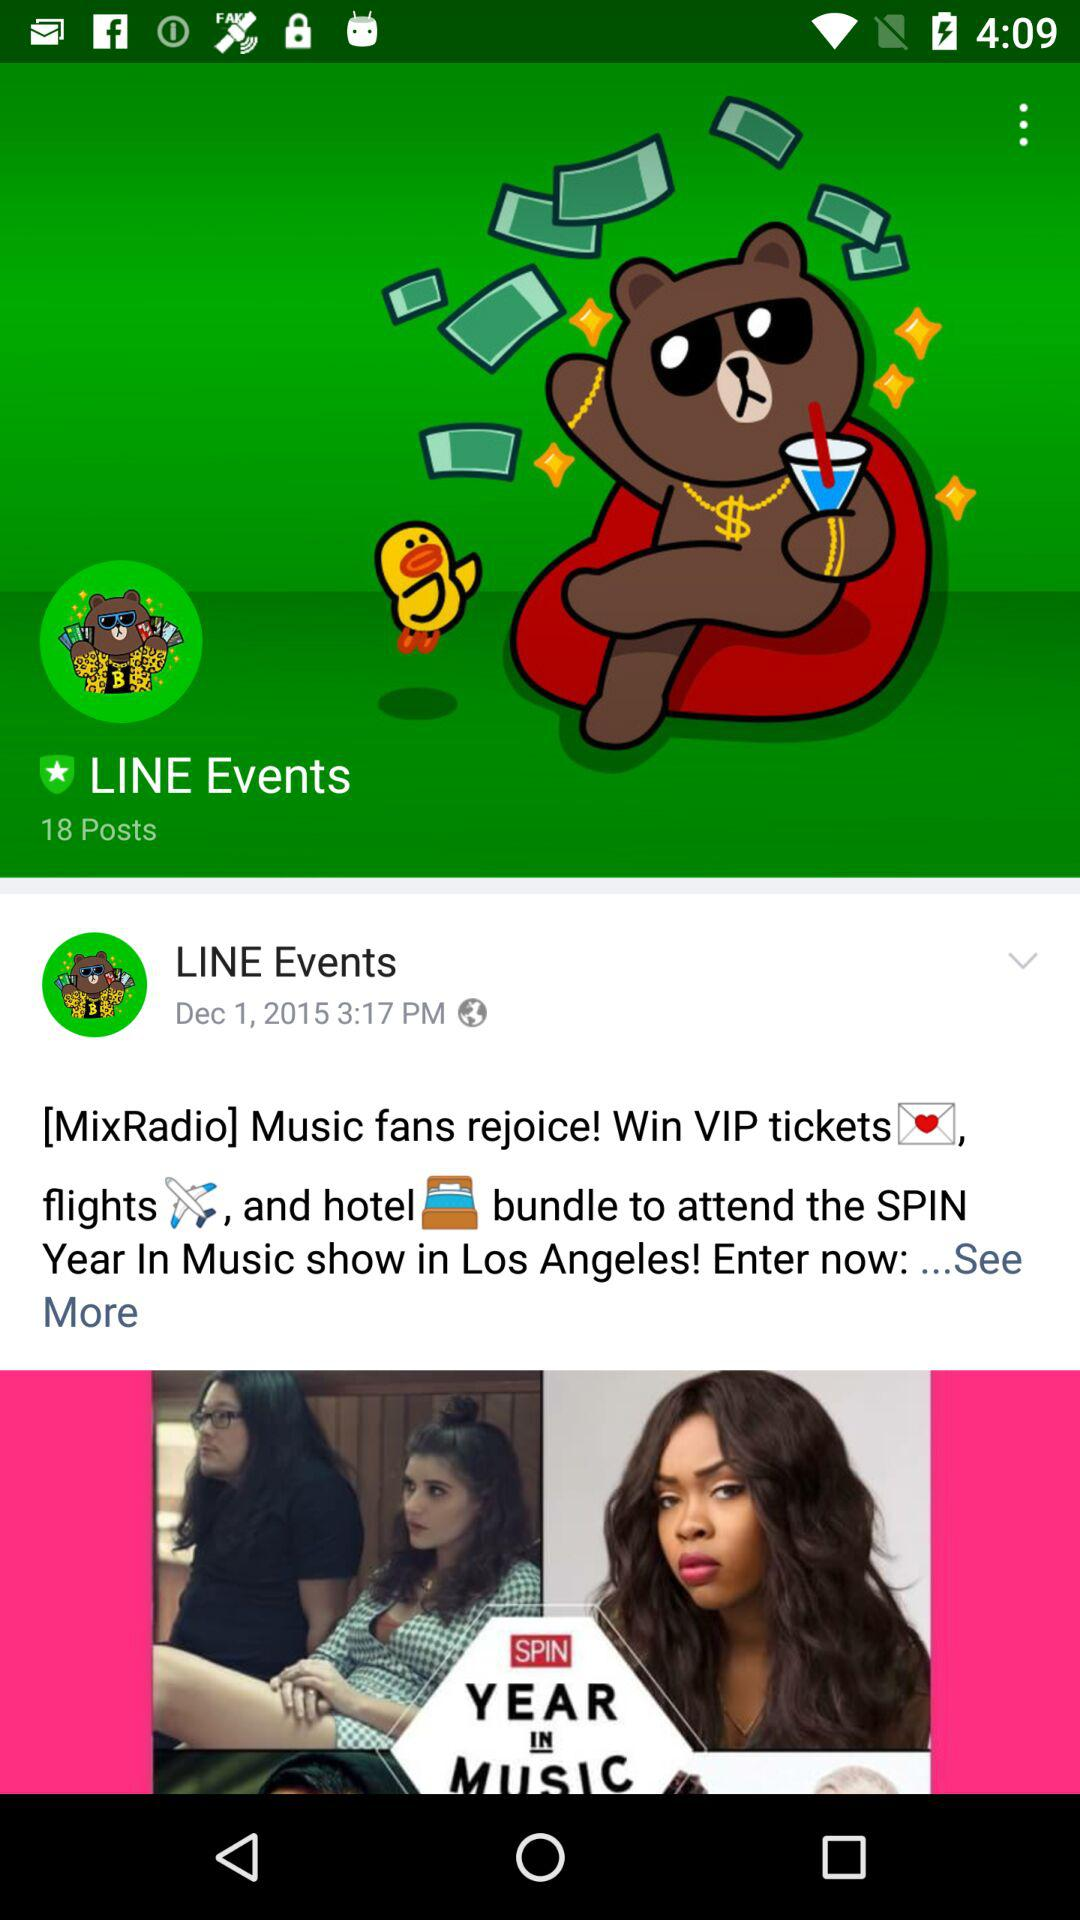What is the name of the application? The application name is LINE. 